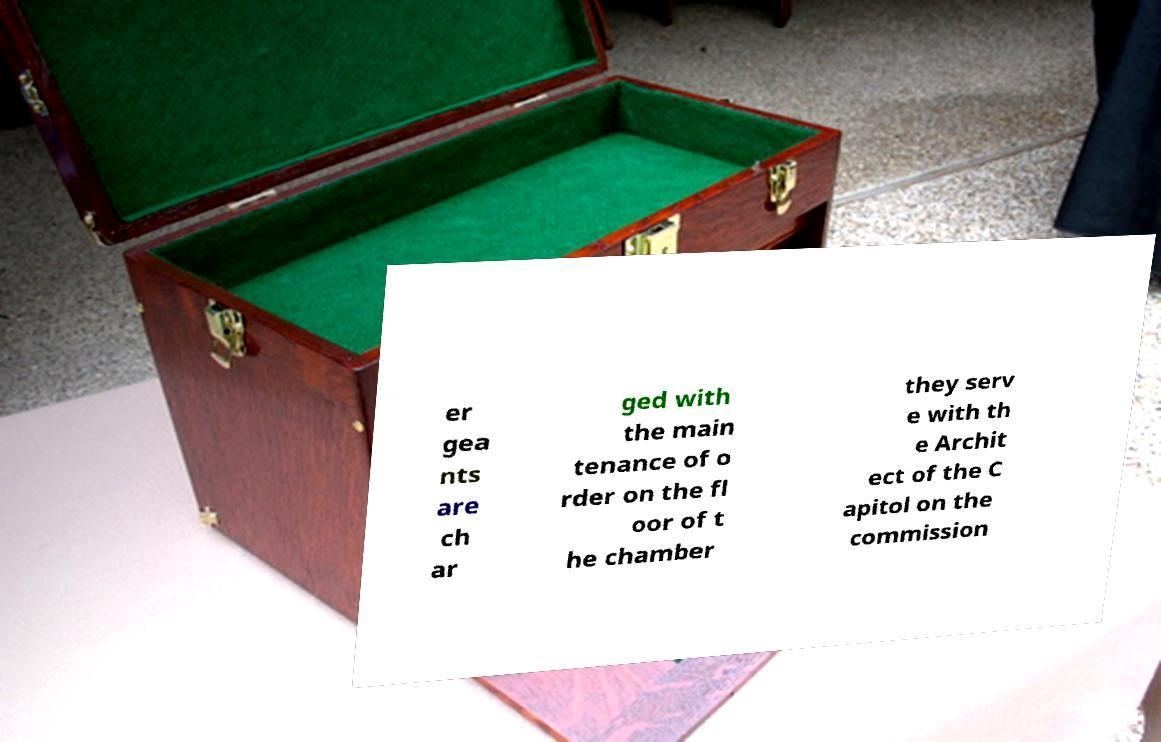I need the written content from this picture converted into text. Can you do that? er gea nts are ch ar ged with the main tenance of o rder on the fl oor of t he chamber they serv e with th e Archit ect of the C apitol on the commission 